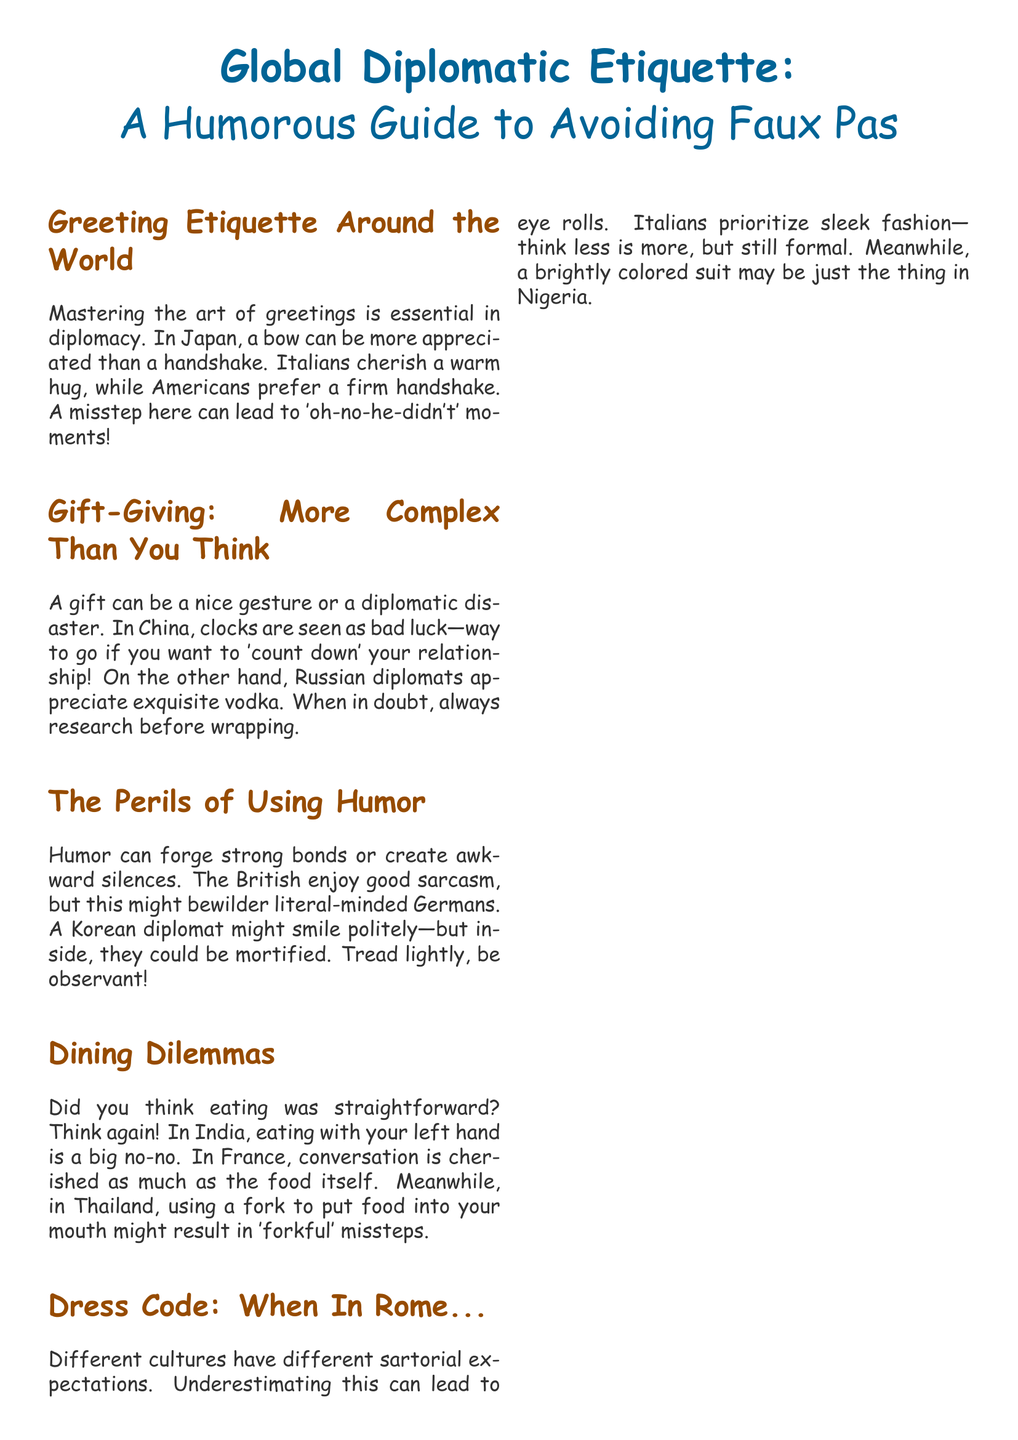What is the main title of the document? The main title "Global Diplomatic Etiquette" introduces the focus of the document on diplomatic interactions.
Answer: Global Diplomatic Etiquette What one word is used to describe the guide? The document describes the guide as "Humorous," indicating a lighthearted approach to serious topics.
Answer: Humorous In which country is using a bow preferred over a handshake? Japan's greeting customs emphasize bowing over handshaking as a sign of respect.
Answer: Japan What unique gift is appreciated by Russian diplomats? The document indicates that Russian diplomats favor exquisite vodka as a preferred gift.
Answer: Vodka What is a dining no-no when eating in India? The document notes that using the left hand for eating in India is considered unacceptable and inappropriate.
Answer: Left hand Which country’s diplomats might be bewildered by sarcasm? Germans are mentioned in the document as being more literal-minded and might not understand British sarcasm.
Answer: Germans What sartorial expectation is highlighted for Italians? The document emphasizes that Italians prioritize sleek fashion, which suggests an understanding of stylish yet formal dress.
Answer: Sleek fashion What humor did a U.S. ambassador use during a British dinner? The U.S. ambassador joked about "backstabbing," which adds a humorous dimension to the diplomatic tension.
Answer: Backstabbing What is advised to remember about smiles in diplomacy? The final note in the document advises that while smiles are universal, other expressions may vary and are negotiable.
Answer: A smile is universal 